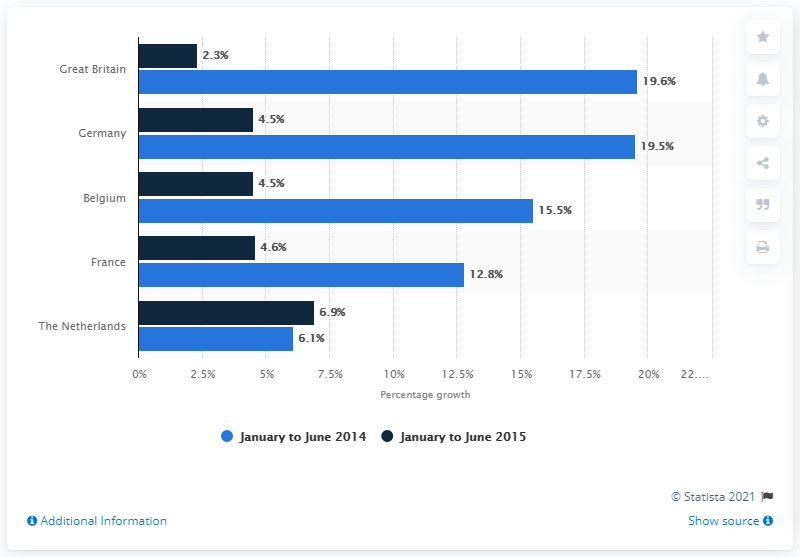Draw attention to some important aspects in this diagram. Germany's gardening equipment sales increased by 4.5% between January and June 2015. The difference between the highest growth in retail sales in Germany and the lowest growth in retail sales in France is 14.9%. The highest value of the navy blue bar is 6.9. 